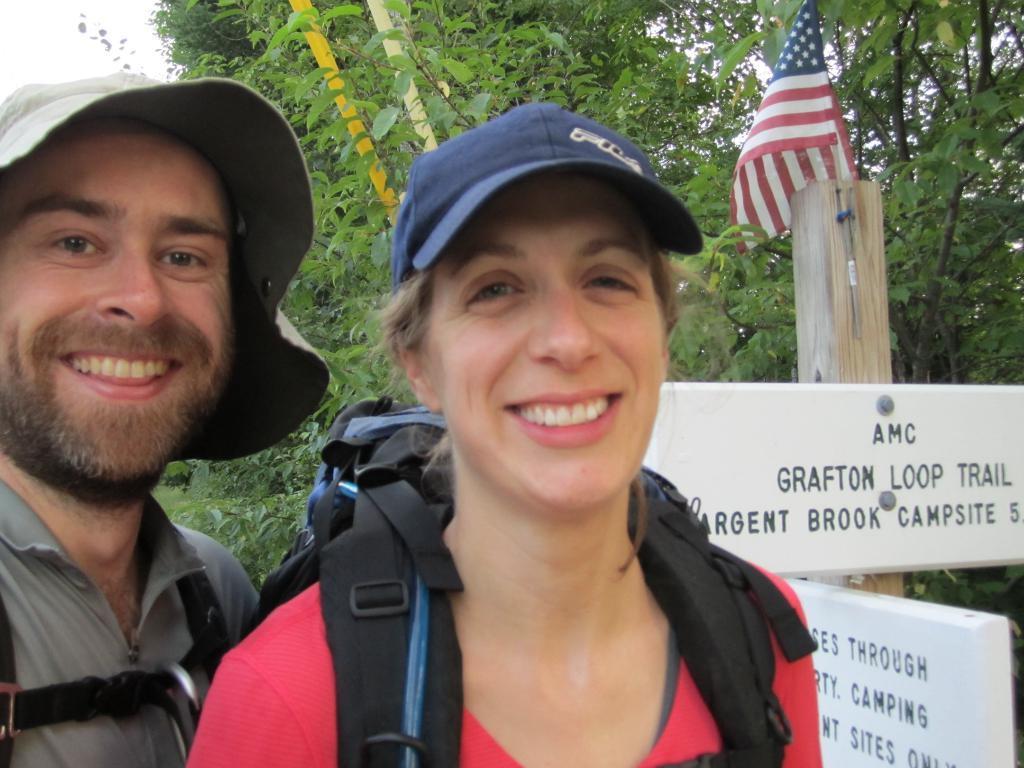Can you describe this image briefly? In this image I can see a man and a woman wearing bags and caps are smiling. I can see a wooden pole and to it I can see a flag and few boards. In the background I can see few trees which are green in color and the sky. 